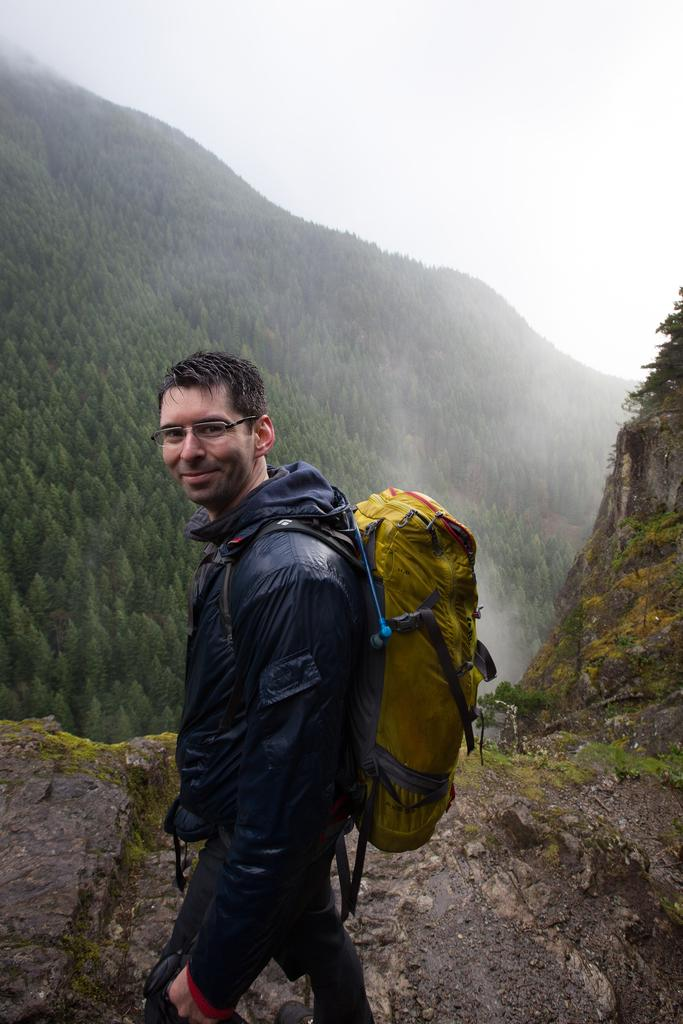What can be seen in the background of the image? There is a sky in the image. What type of natural elements are present in the image? There are trees in the image. What is the man in the image wearing? The man in the image is wearing a bag. Is the man in the image sleeping with his chin on his chest? There is no indication in the image that the man is sleeping or resting his chin on his chest. 